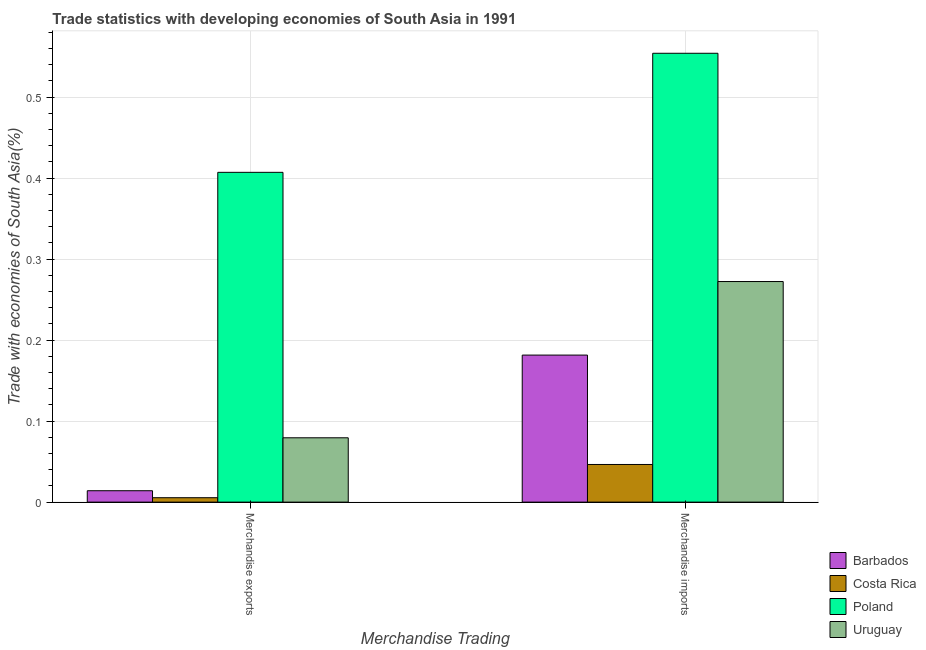How many different coloured bars are there?
Ensure brevity in your answer.  4. Are the number of bars per tick equal to the number of legend labels?
Keep it short and to the point. Yes. How many bars are there on the 1st tick from the right?
Provide a short and direct response. 4. What is the label of the 1st group of bars from the left?
Your response must be concise. Merchandise exports. What is the merchandise exports in Poland?
Your response must be concise. 0.41. Across all countries, what is the maximum merchandise imports?
Your answer should be compact. 0.55. Across all countries, what is the minimum merchandise exports?
Your answer should be compact. 0.01. In which country was the merchandise exports minimum?
Your answer should be compact. Costa Rica. What is the total merchandise exports in the graph?
Offer a terse response. 0.51. What is the difference between the merchandise exports in Costa Rica and that in Barbados?
Your response must be concise. -0.01. What is the difference between the merchandise imports in Costa Rica and the merchandise exports in Barbados?
Your answer should be compact. 0.03. What is the average merchandise exports per country?
Your answer should be compact. 0.13. What is the difference between the merchandise imports and merchandise exports in Barbados?
Your answer should be compact. 0.17. In how many countries, is the merchandise imports greater than 0.18 %?
Provide a short and direct response. 3. What is the ratio of the merchandise imports in Barbados to that in Uruguay?
Your answer should be very brief. 0.67. What does the 2nd bar from the left in Merchandise imports represents?
Make the answer very short. Costa Rica. What does the 1st bar from the right in Merchandise exports represents?
Offer a terse response. Uruguay. How many bars are there?
Provide a succinct answer. 8. Are all the bars in the graph horizontal?
Ensure brevity in your answer.  No. How many countries are there in the graph?
Give a very brief answer. 4. Does the graph contain any zero values?
Provide a short and direct response. No. How many legend labels are there?
Provide a succinct answer. 4. What is the title of the graph?
Offer a terse response. Trade statistics with developing economies of South Asia in 1991. Does "Nicaragua" appear as one of the legend labels in the graph?
Provide a succinct answer. No. What is the label or title of the X-axis?
Offer a very short reply. Merchandise Trading. What is the label or title of the Y-axis?
Ensure brevity in your answer.  Trade with economies of South Asia(%). What is the Trade with economies of South Asia(%) of Barbados in Merchandise exports?
Offer a terse response. 0.01. What is the Trade with economies of South Asia(%) in Costa Rica in Merchandise exports?
Your answer should be very brief. 0.01. What is the Trade with economies of South Asia(%) in Poland in Merchandise exports?
Offer a very short reply. 0.41. What is the Trade with economies of South Asia(%) in Uruguay in Merchandise exports?
Make the answer very short. 0.08. What is the Trade with economies of South Asia(%) in Barbados in Merchandise imports?
Your response must be concise. 0.18. What is the Trade with economies of South Asia(%) in Costa Rica in Merchandise imports?
Offer a very short reply. 0.05. What is the Trade with economies of South Asia(%) in Poland in Merchandise imports?
Your response must be concise. 0.55. What is the Trade with economies of South Asia(%) of Uruguay in Merchandise imports?
Offer a very short reply. 0.27. Across all Merchandise Trading, what is the maximum Trade with economies of South Asia(%) of Barbados?
Offer a terse response. 0.18. Across all Merchandise Trading, what is the maximum Trade with economies of South Asia(%) of Costa Rica?
Provide a succinct answer. 0.05. Across all Merchandise Trading, what is the maximum Trade with economies of South Asia(%) in Poland?
Make the answer very short. 0.55. Across all Merchandise Trading, what is the maximum Trade with economies of South Asia(%) in Uruguay?
Your answer should be very brief. 0.27. Across all Merchandise Trading, what is the minimum Trade with economies of South Asia(%) of Barbados?
Ensure brevity in your answer.  0.01. Across all Merchandise Trading, what is the minimum Trade with economies of South Asia(%) of Costa Rica?
Give a very brief answer. 0.01. Across all Merchandise Trading, what is the minimum Trade with economies of South Asia(%) in Poland?
Your response must be concise. 0.41. Across all Merchandise Trading, what is the minimum Trade with economies of South Asia(%) of Uruguay?
Provide a succinct answer. 0.08. What is the total Trade with economies of South Asia(%) of Barbados in the graph?
Your answer should be very brief. 0.2. What is the total Trade with economies of South Asia(%) in Costa Rica in the graph?
Ensure brevity in your answer.  0.05. What is the total Trade with economies of South Asia(%) in Poland in the graph?
Keep it short and to the point. 0.96. What is the total Trade with economies of South Asia(%) of Uruguay in the graph?
Give a very brief answer. 0.35. What is the difference between the Trade with economies of South Asia(%) of Barbados in Merchandise exports and that in Merchandise imports?
Give a very brief answer. -0.17. What is the difference between the Trade with economies of South Asia(%) in Costa Rica in Merchandise exports and that in Merchandise imports?
Give a very brief answer. -0.04. What is the difference between the Trade with economies of South Asia(%) in Poland in Merchandise exports and that in Merchandise imports?
Offer a terse response. -0.15. What is the difference between the Trade with economies of South Asia(%) of Uruguay in Merchandise exports and that in Merchandise imports?
Your answer should be very brief. -0.19. What is the difference between the Trade with economies of South Asia(%) in Barbados in Merchandise exports and the Trade with economies of South Asia(%) in Costa Rica in Merchandise imports?
Your answer should be very brief. -0.03. What is the difference between the Trade with economies of South Asia(%) of Barbados in Merchandise exports and the Trade with economies of South Asia(%) of Poland in Merchandise imports?
Give a very brief answer. -0.54. What is the difference between the Trade with economies of South Asia(%) in Barbados in Merchandise exports and the Trade with economies of South Asia(%) in Uruguay in Merchandise imports?
Offer a terse response. -0.26. What is the difference between the Trade with economies of South Asia(%) in Costa Rica in Merchandise exports and the Trade with economies of South Asia(%) in Poland in Merchandise imports?
Your answer should be compact. -0.55. What is the difference between the Trade with economies of South Asia(%) in Costa Rica in Merchandise exports and the Trade with economies of South Asia(%) in Uruguay in Merchandise imports?
Your answer should be very brief. -0.27. What is the difference between the Trade with economies of South Asia(%) in Poland in Merchandise exports and the Trade with economies of South Asia(%) in Uruguay in Merchandise imports?
Offer a terse response. 0.13. What is the average Trade with economies of South Asia(%) of Barbados per Merchandise Trading?
Ensure brevity in your answer.  0.1. What is the average Trade with economies of South Asia(%) of Costa Rica per Merchandise Trading?
Provide a succinct answer. 0.03. What is the average Trade with economies of South Asia(%) of Poland per Merchandise Trading?
Your answer should be compact. 0.48. What is the average Trade with economies of South Asia(%) of Uruguay per Merchandise Trading?
Offer a terse response. 0.18. What is the difference between the Trade with economies of South Asia(%) of Barbados and Trade with economies of South Asia(%) of Costa Rica in Merchandise exports?
Your answer should be compact. 0.01. What is the difference between the Trade with economies of South Asia(%) in Barbados and Trade with economies of South Asia(%) in Poland in Merchandise exports?
Make the answer very short. -0.39. What is the difference between the Trade with economies of South Asia(%) of Barbados and Trade with economies of South Asia(%) of Uruguay in Merchandise exports?
Your answer should be very brief. -0.07. What is the difference between the Trade with economies of South Asia(%) of Costa Rica and Trade with economies of South Asia(%) of Poland in Merchandise exports?
Provide a succinct answer. -0.4. What is the difference between the Trade with economies of South Asia(%) in Costa Rica and Trade with economies of South Asia(%) in Uruguay in Merchandise exports?
Give a very brief answer. -0.07. What is the difference between the Trade with economies of South Asia(%) in Poland and Trade with economies of South Asia(%) in Uruguay in Merchandise exports?
Your answer should be very brief. 0.33. What is the difference between the Trade with economies of South Asia(%) of Barbados and Trade with economies of South Asia(%) of Costa Rica in Merchandise imports?
Offer a very short reply. 0.14. What is the difference between the Trade with economies of South Asia(%) in Barbados and Trade with economies of South Asia(%) in Poland in Merchandise imports?
Your response must be concise. -0.37. What is the difference between the Trade with economies of South Asia(%) in Barbados and Trade with economies of South Asia(%) in Uruguay in Merchandise imports?
Your answer should be very brief. -0.09. What is the difference between the Trade with economies of South Asia(%) of Costa Rica and Trade with economies of South Asia(%) of Poland in Merchandise imports?
Give a very brief answer. -0.51. What is the difference between the Trade with economies of South Asia(%) of Costa Rica and Trade with economies of South Asia(%) of Uruguay in Merchandise imports?
Provide a succinct answer. -0.23. What is the difference between the Trade with economies of South Asia(%) of Poland and Trade with economies of South Asia(%) of Uruguay in Merchandise imports?
Your answer should be compact. 0.28. What is the ratio of the Trade with economies of South Asia(%) of Barbados in Merchandise exports to that in Merchandise imports?
Provide a succinct answer. 0.08. What is the ratio of the Trade with economies of South Asia(%) of Costa Rica in Merchandise exports to that in Merchandise imports?
Make the answer very short. 0.12. What is the ratio of the Trade with economies of South Asia(%) of Poland in Merchandise exports to that in Merchandise imports?
Provide a short and direct response. 0.73. What is the ratio of the Trade with economies of South Asia(%) in Uruguay in Merchandise exports to that in Merchandise imports?
Your answer should be very brief. 0.29. What is the difference between the highest and the second highest Trade with economies of South Asia(%) of Barbados?
Offer a terse response. 0.17. What is the difference between the highest and the second highest Trade with economies of South Asia(%) of Costa Rica?
Give a very brief answer. 0.04. What is the difference between the highest and the second highest Trade with economies of South Asia(%) in Poland?
Ensure brevity in your answer.  0.15. What is the difference between the highest and the second highest Trade with economies of South Asia(%) in Uruguay?
Your response must be concise. 0.19. What is the difference between the highest and the lowest Trade with economies of South Asia(%) of Barbados?
Give a very brief answer. 0.17. What is the difference between the highest and the lowest Trade with economies of South Asia(%) of Costa Rica?
Your answer should be very brief. 0.04. What is the difference between the highest and the lowest Trade with economies of South Asia(%) of Poland?
Keep it short and to the point. 0.15. What is the difference between the highest and the lowest Trade with economies of South Asia(%) of Uruguay?
Offer a terse response. 0.19. 